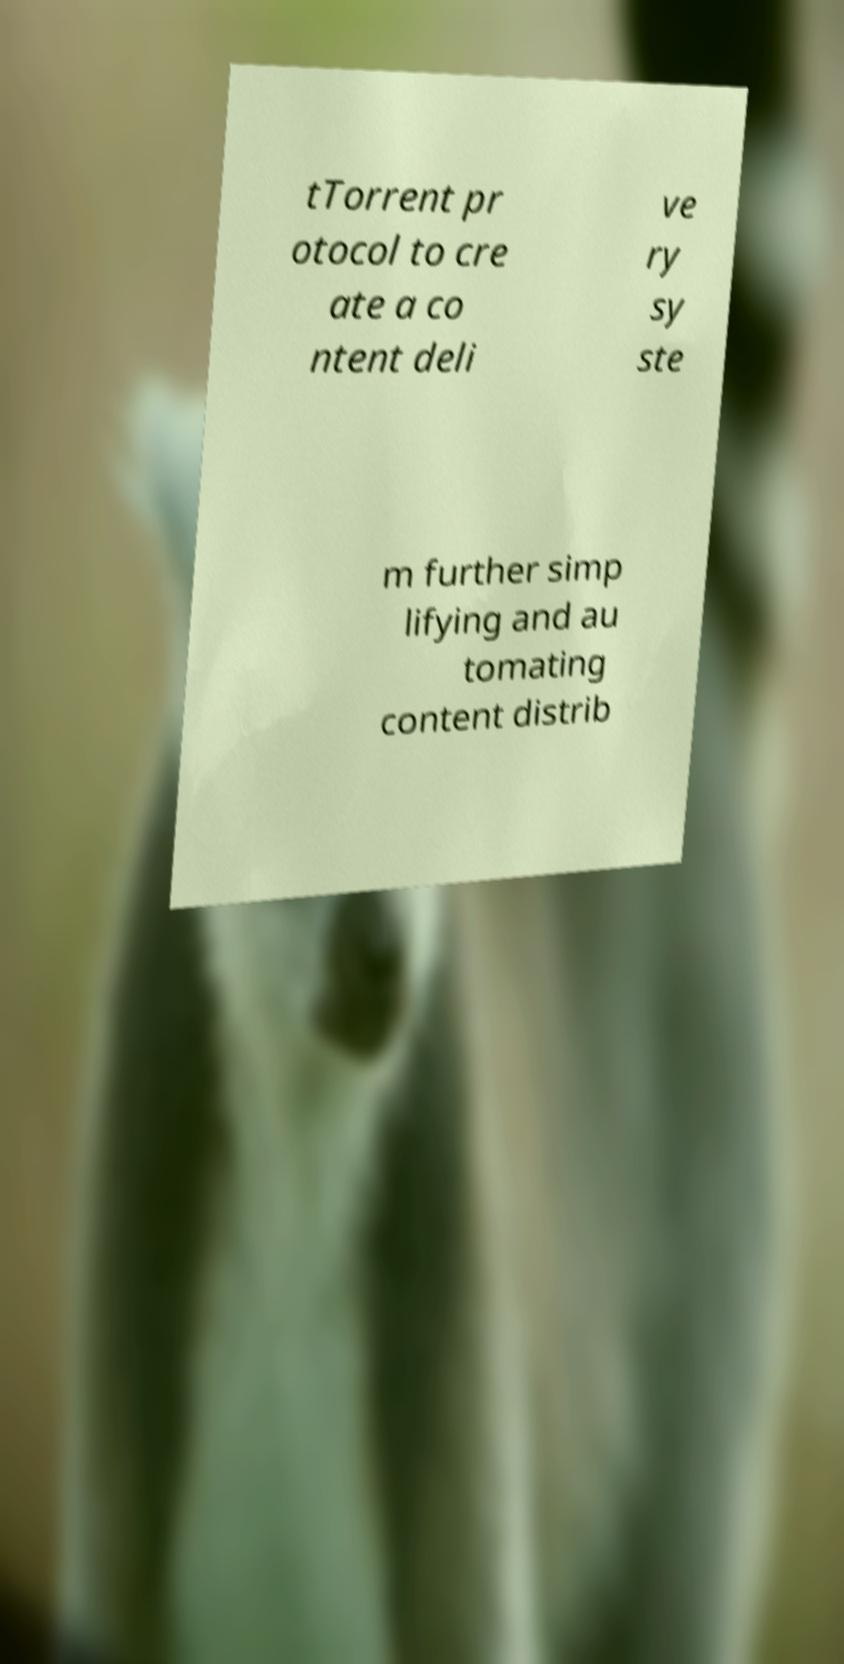I need the written content from this picture converted into text. Can you do that? tTorrent pr otocol to cre ate a co ntent deli ve ry sy ste m further simp lifying and au tomating content distrib 